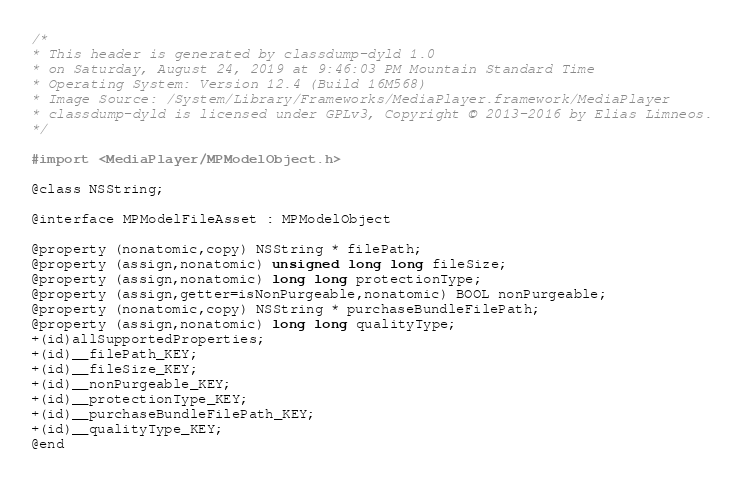<code> <loc_0><loc_0><loc_500><loc_500><_C_>/*
* This header is generated by classdump-dyld 1.0
* on Saturday, August 24, 2019 at 9:46:03 PM Mountain Standard Time
* Operating System: Version 12.4 (Build 16M568)
* Image Source: /System/Library/Frameworks/MediaPlayer.framework/MediaPlayer
* classdump-dyld is licensed under GPLv3, Copyright © 2013-2016 by Elias Limneos.
*/

#import <MediaPlayer/MPModelObject.h>

@class NSString;

@interface MPModelFileAsset : MPModelObject

@property (nonatomic,copy) NSString * filePath; 
@property (assign,nonatomic) unsigned long long fileSize; 
@property (assign,nonatomic) long long protectionType; 
@property (assign,getter=isNonPurgeable,nonatomic) BOOL nonPurgeable; 
@property (nonatomic,copy) NSString * purchaseBundleFilePath; 
@property (assign,nonatomic) long long qualityType; 
+(id)allSupportedProperties;
+(id)__filePath_KEY;
+(id)__fileSize_KEY;
+(id)__nonPurgeable_KEY;
+(id)__protectionType_KEY;
+(id)__purchaseBundleFilePath_KEY;
+(id)__qualityType_KEY;
@end

</code> 